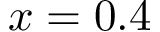Convert formula to latex. <formula><loc_0><loc_0><loc_500><loc_500>x = 0 . 4</formula> 